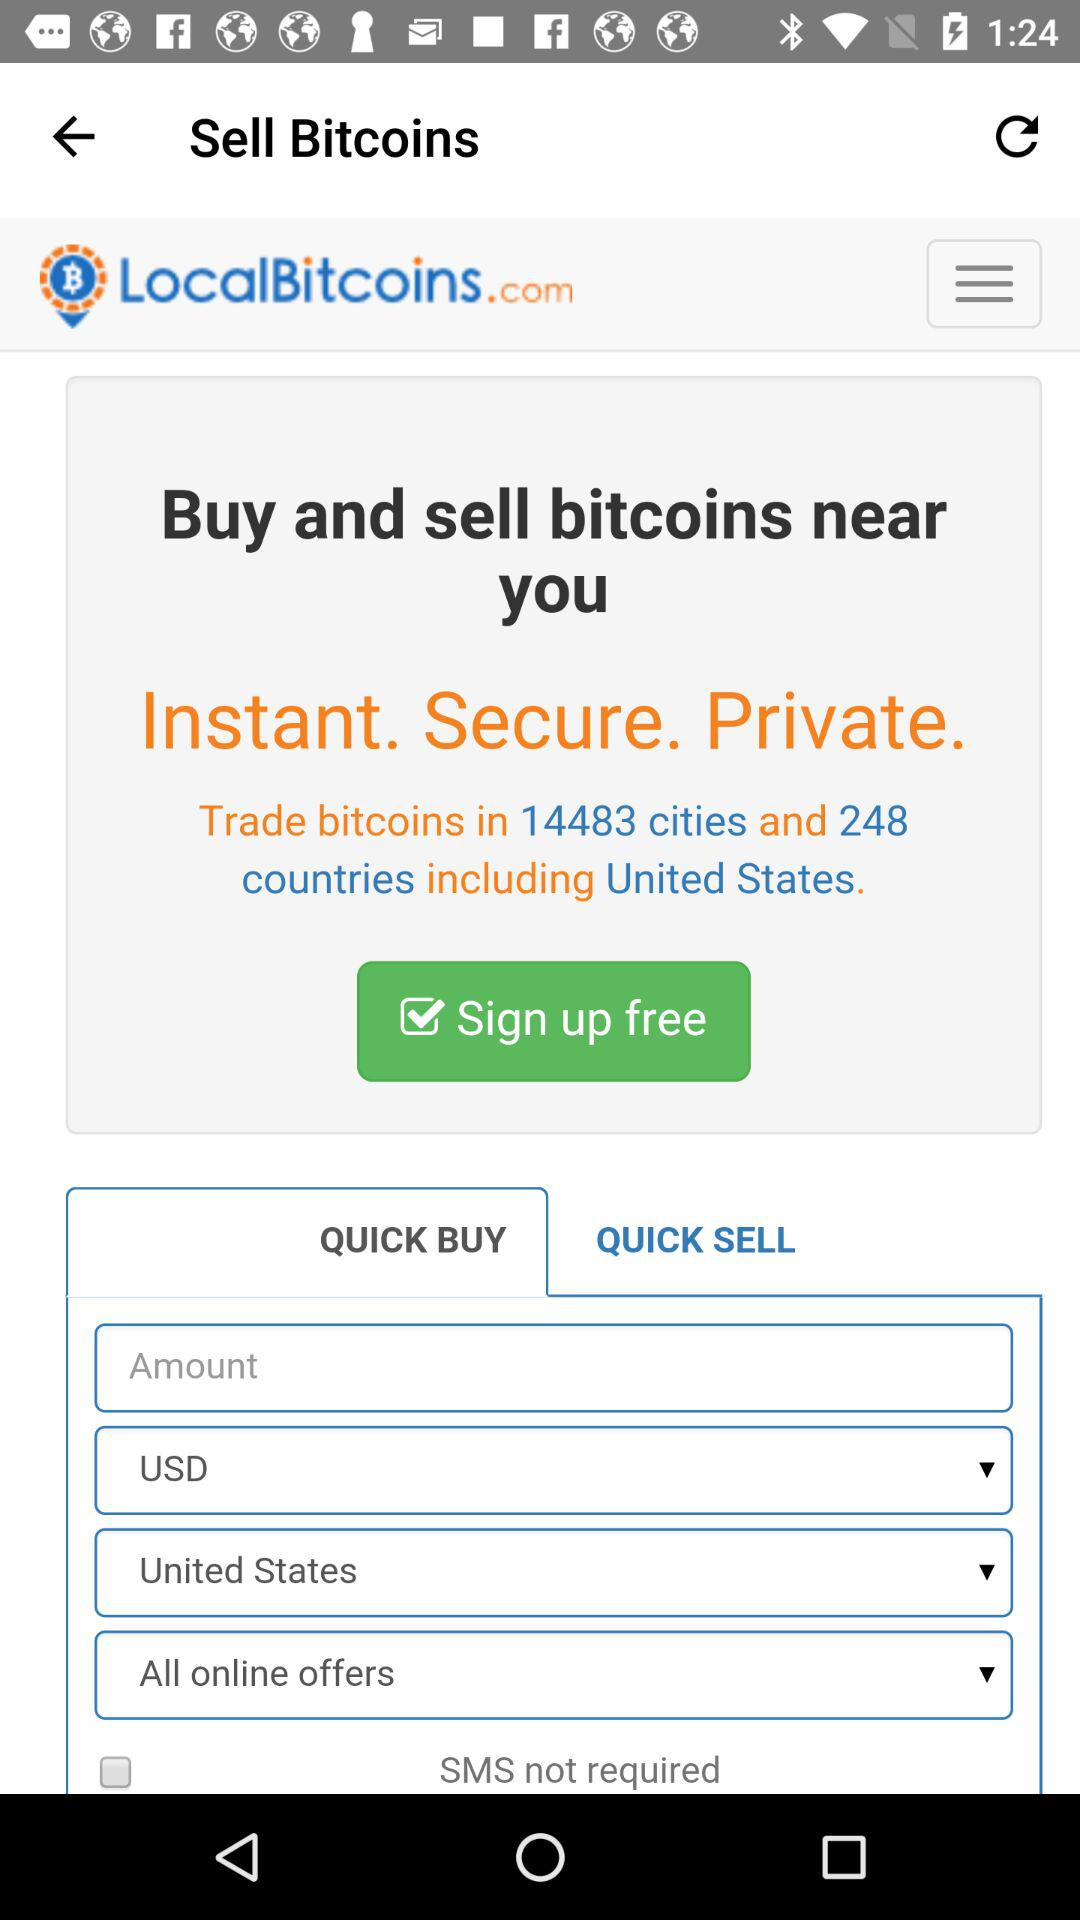Which country is included in all countries for bitcoins trading? The country that is included in all countries for bitcoins trading is the United States. 